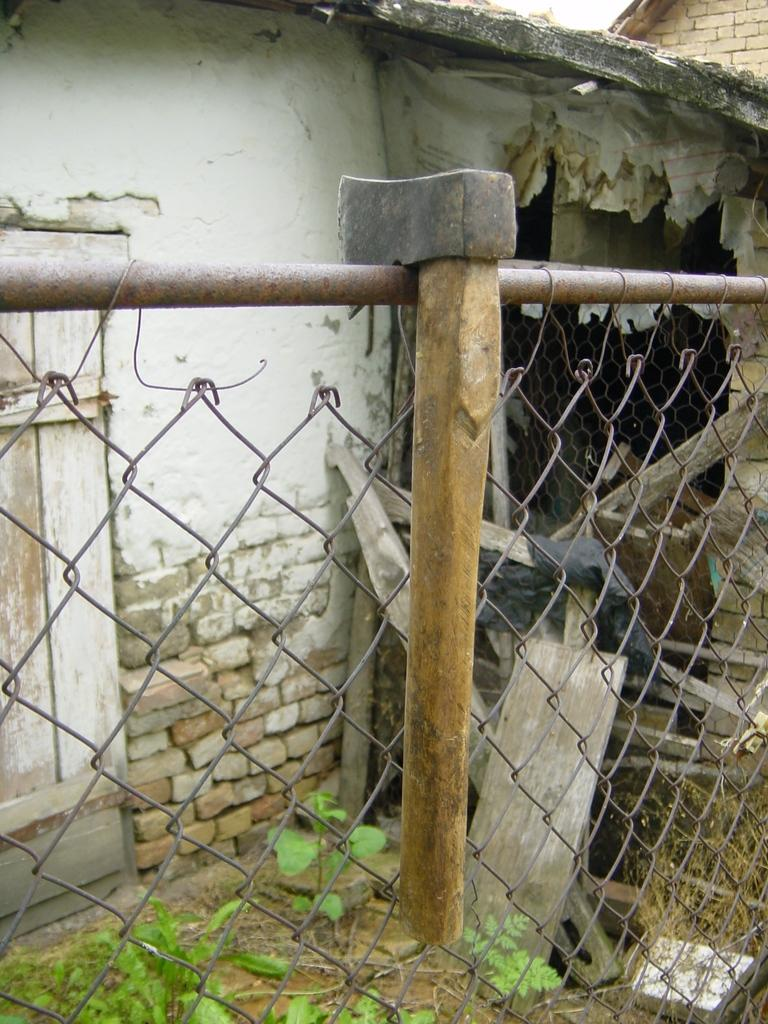What object is attached to the fence in the image? There is a hammer attached to a fence in the image. What can be seen in the background of the image? There is a building visible in the image. What type of vegetation is present in the image? There are plants in the image. Where is the lunchroom located in the image? There is no mention of a lunchroom in the image; it only features a hammer, a fence, a building, and plants. 